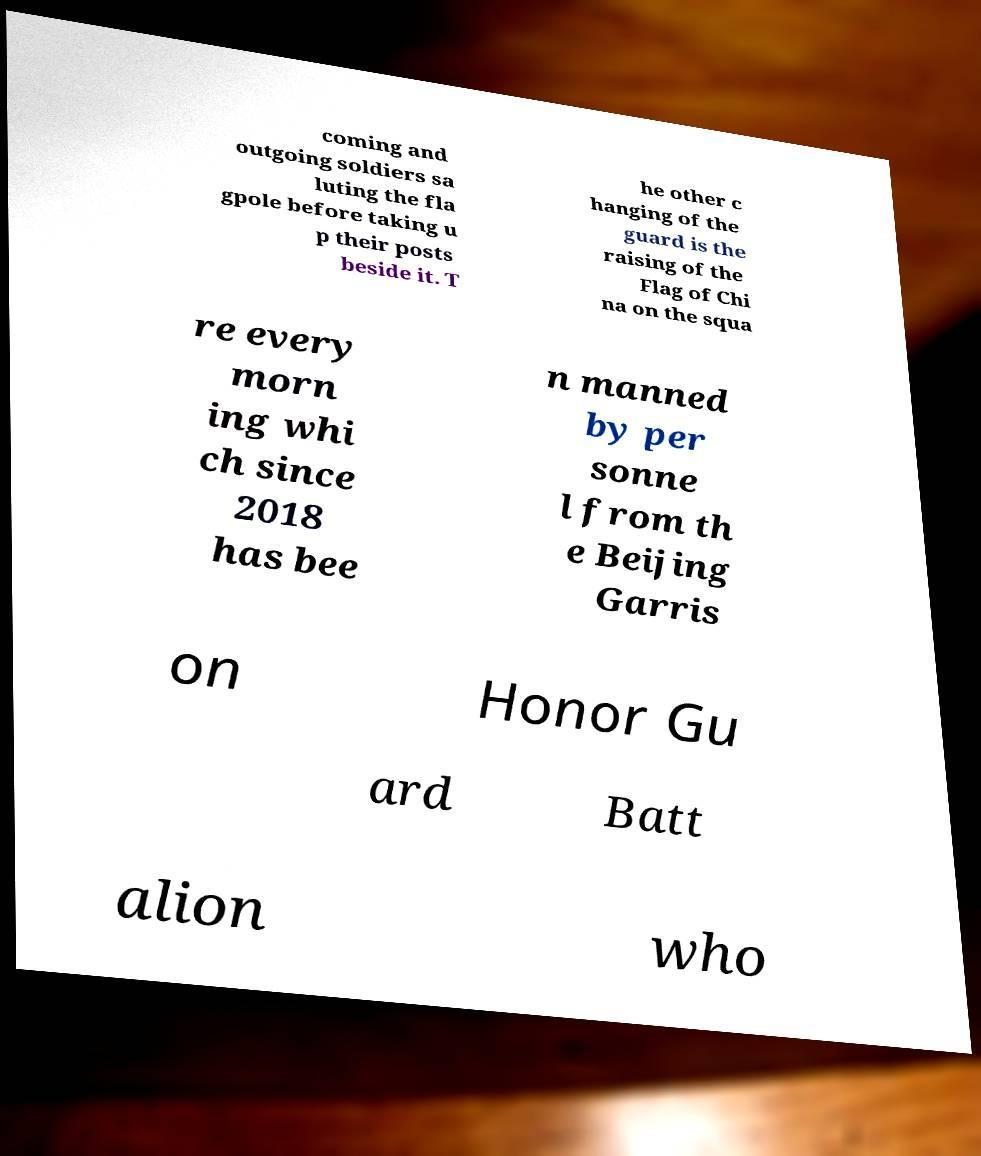Can you accurately transcribe the text from the provided image for me? coming and outgoing soldiers sa luting the fla gpole before taking u p their posts beside it. T he other c hanging of the guard is the raising of the Flag of Chi na on the squa re every morn ing whi ch since 2018 has bee n manned by per sonne l from th e Beijing Garris on Honor Gu ard Batt alion who 